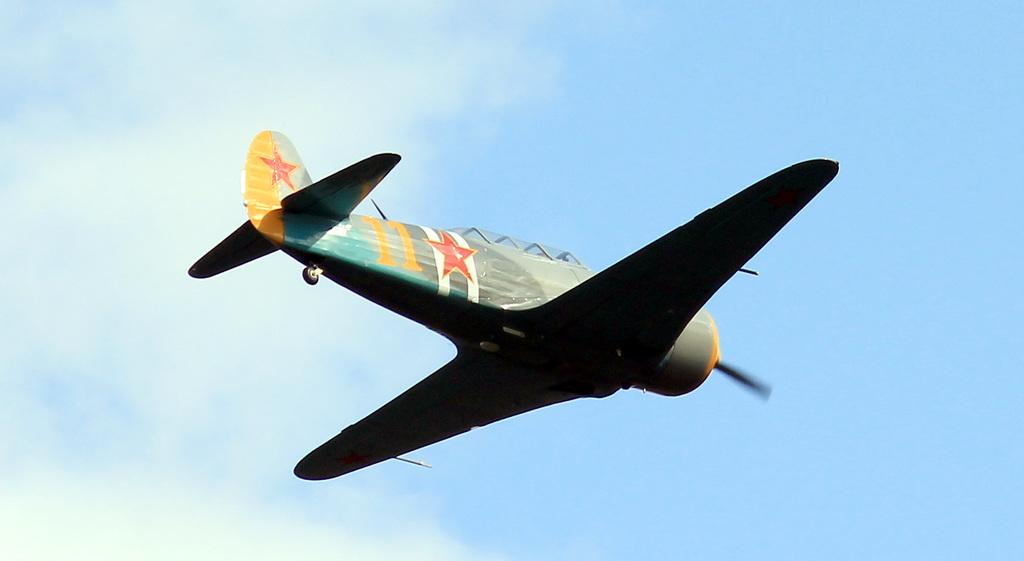What is the main subject of the image? The main subject of the image is an airplane. Where is the airplane located in the image? The airplane is in the air. What else can be seen in the image besides the airplane? The sky is visible in the image. How many eyes can be seen on the airplane in the image? There are no eyes visible on the airplane in the image, as airplanes do not have eyes. 